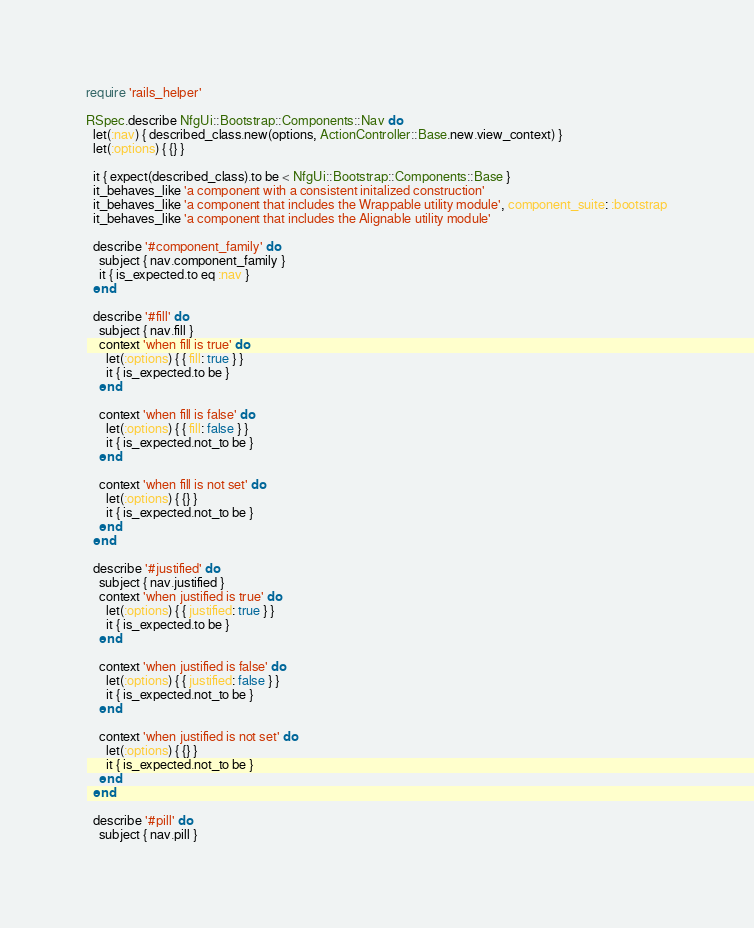<code> <loc_0><loc_0><loc_500><loc_500><_Ruby_>require 'rails_helper'

RSpec.describe NfgUi::Bootstrap::Components::Nav do
  let(:nav) { described_class.new(options, ActionController::Base.new.view_context) }
  let(:options) { {} }

  it { expect(described_class).to be < NfgUi::Bootstrap::Components::Base }
  it_behaves_like 'a component with a consistent initalized construction'
  it_behaves_like 'a component that includes the Wrappable utility module', component_suite: :bootstrap
  it_behaves_like 'a component that includes the Alignable utility module'

  describe '#component_family' do
    subject { nav.component_family }
    it { is_expected.to eq :nav }
  end

  describe '#fill' do
    subject { nav.fill }
    context 'when fill is true' do
      let(:options) { { fill: true } }
      it { is_expected.to be }
    end

    context 'when fill is false' do
      let(:options) { { fill: false } }
      it { is_expected.not_to be }
    end

    context 'when fill is not set' do
      let(:options) { {} }
      it { is_expected.not_to be }
    end
  end

  describe '#justified' do
    subject { nav.justified }
    context 'when justified is true' do
      let(:options) { { justified: true } }
      it { is_expected.to be }
    end

    context 'when justified is false' do
      let(:options) { { justified: false } }
      it { is_expected.not_to be }
    end

    context 'when justified is not set' do
      let(:options) { {} }
      it { is_expected.not_to be }
    end
  end

  describe '#pill' do
    subject { nav.pill }</code> 